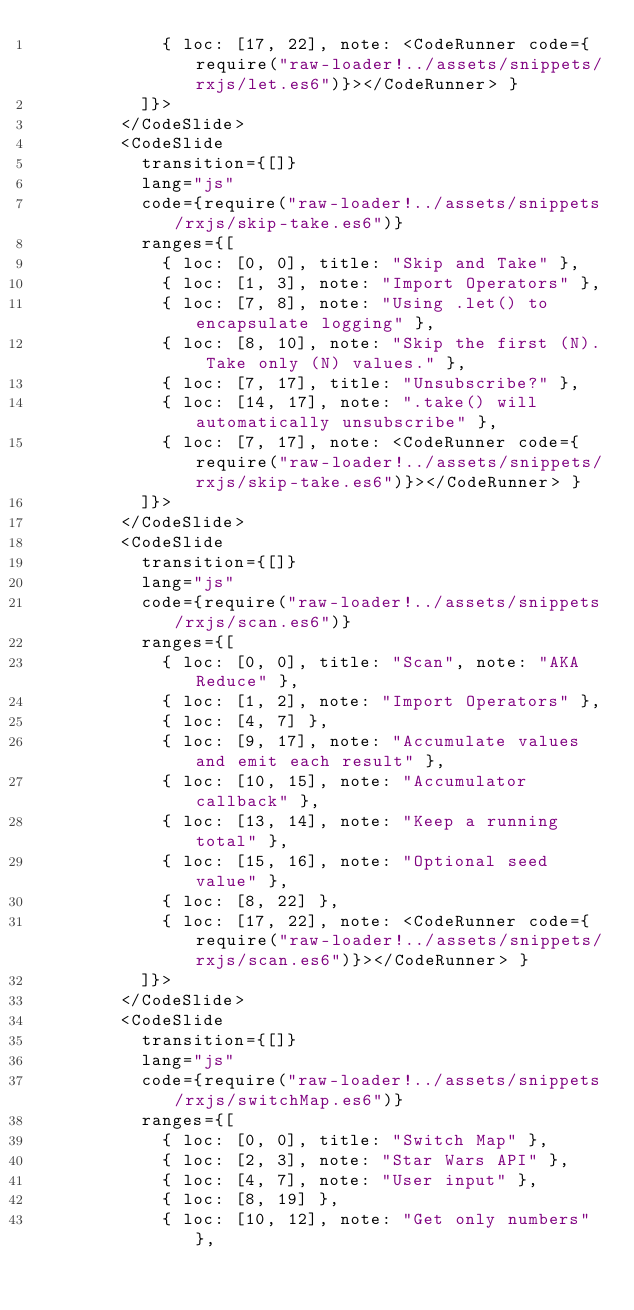Convert code to text. <code><loc_0><loc_0><loc_500><loc_500><_JavaScript_>            { loc: [17, 22], note: <CodeRunner code={require("raw-loader!../assets/snippets/rxjs/let.es6")}></CodeRunner> }
          ]}>
        </CodeSlide>
        <CodeSlide
          transition={[]}
          lang="js"
          code={require("raw-loader!../assets/snippets/rxjs/skip-take.es6")}
          ranges={[
            { loc: [0, 0], title: "Skip and Take" },
            { loc: [1, 3], note: "Import Operators" },
            { loc: [7, 8], note: "Using .let() to encapsulate logging" },
            { loc: [8, 10], note: "Skip the first (N). Take only (N) values." },
            { loc: [7, 17], title: "Unsubscribe?" },
            { loc: [14, 17], note: ".take() will automatically unsubscribe" },
            { loc: [7, 17], note: <CodeRunner code={require("raw-loader!../assets/snippets/rxjs/skip-take.es6")}></CodeRunner> }
          ]}>
        </CodeSlide>
        <CodeSlide
          transition={[]}
          lang="js"
          code={require("raw-loader!../assets/snippets/rxjs/scan.es6")}
          ranges={[
            { loc: [0, 0], title: "Scan", note: "AKA Reduce" },
            { loc: [1, 2], note: "Import Operators" },
            { loc: [4, 7] },
            { loc: [9, 17], note: "Accumulate values and emit each result" },
            { loc: [10, 15], note: "Accumulator callback" },
            { loc: [13, 14], note: "Keep a running total" },
            { loc: [15, 16], note: "Optional seed value" },
            { loc: [8, 22] },
            { loc: [17, 22], note: <CodeRunner code={require("raw-loader!../assets/snippets/rxjs/scan.es6")}></CodeRunner> }
          ]}>
        </CodeSlide>
        <CodeSlide
          transition={[]}
          lang="js"
          code={require("raw-loader!../assets/snippets/rxjs/switchMap.es6")}
          ranges={[
            { loc: [0, 0], title: "Switch Map" },
            { loc: [2, 3], note: "Star Wars API" },
            { loc: [4, 7], note: "User input" },
            { loc: [8, 19] },
            { loc: [10, 12], note: "Get only numbers" },</code> 